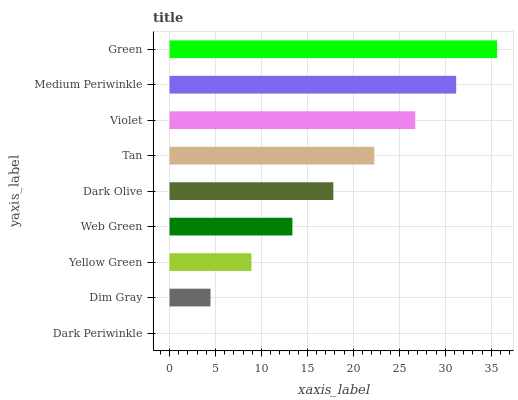Is Dark Periwinkle the minimum?
Answer yes or no. Yes. Is Green the maximum?
Answer yes or no. Yes. Is Dim Gray the minimum?
Answer yes or no. No. Is Dim Gray the maximum?
Answer yes or no. No. Is Dim Gray greater than Dark Periwinkle?
Answer yes or no. Yes. Is Dark Periwinkle less than Dim Gray?
Answer yes or no. Yes. Is Dark Periwinkle greater than Dim Gray?
Answer yes or no. No. Is Dim Gray less than Dark Periwinkle?
Answer yes or no. No. Is Dark Olive the high median?
Answer yes or no. Yes. Is Dark Olive the low median?
Answer yes or no. Yes. Is Green the high median?
Answer yes or no. No. Is Violet the low median?
Answer yes or no. No. 